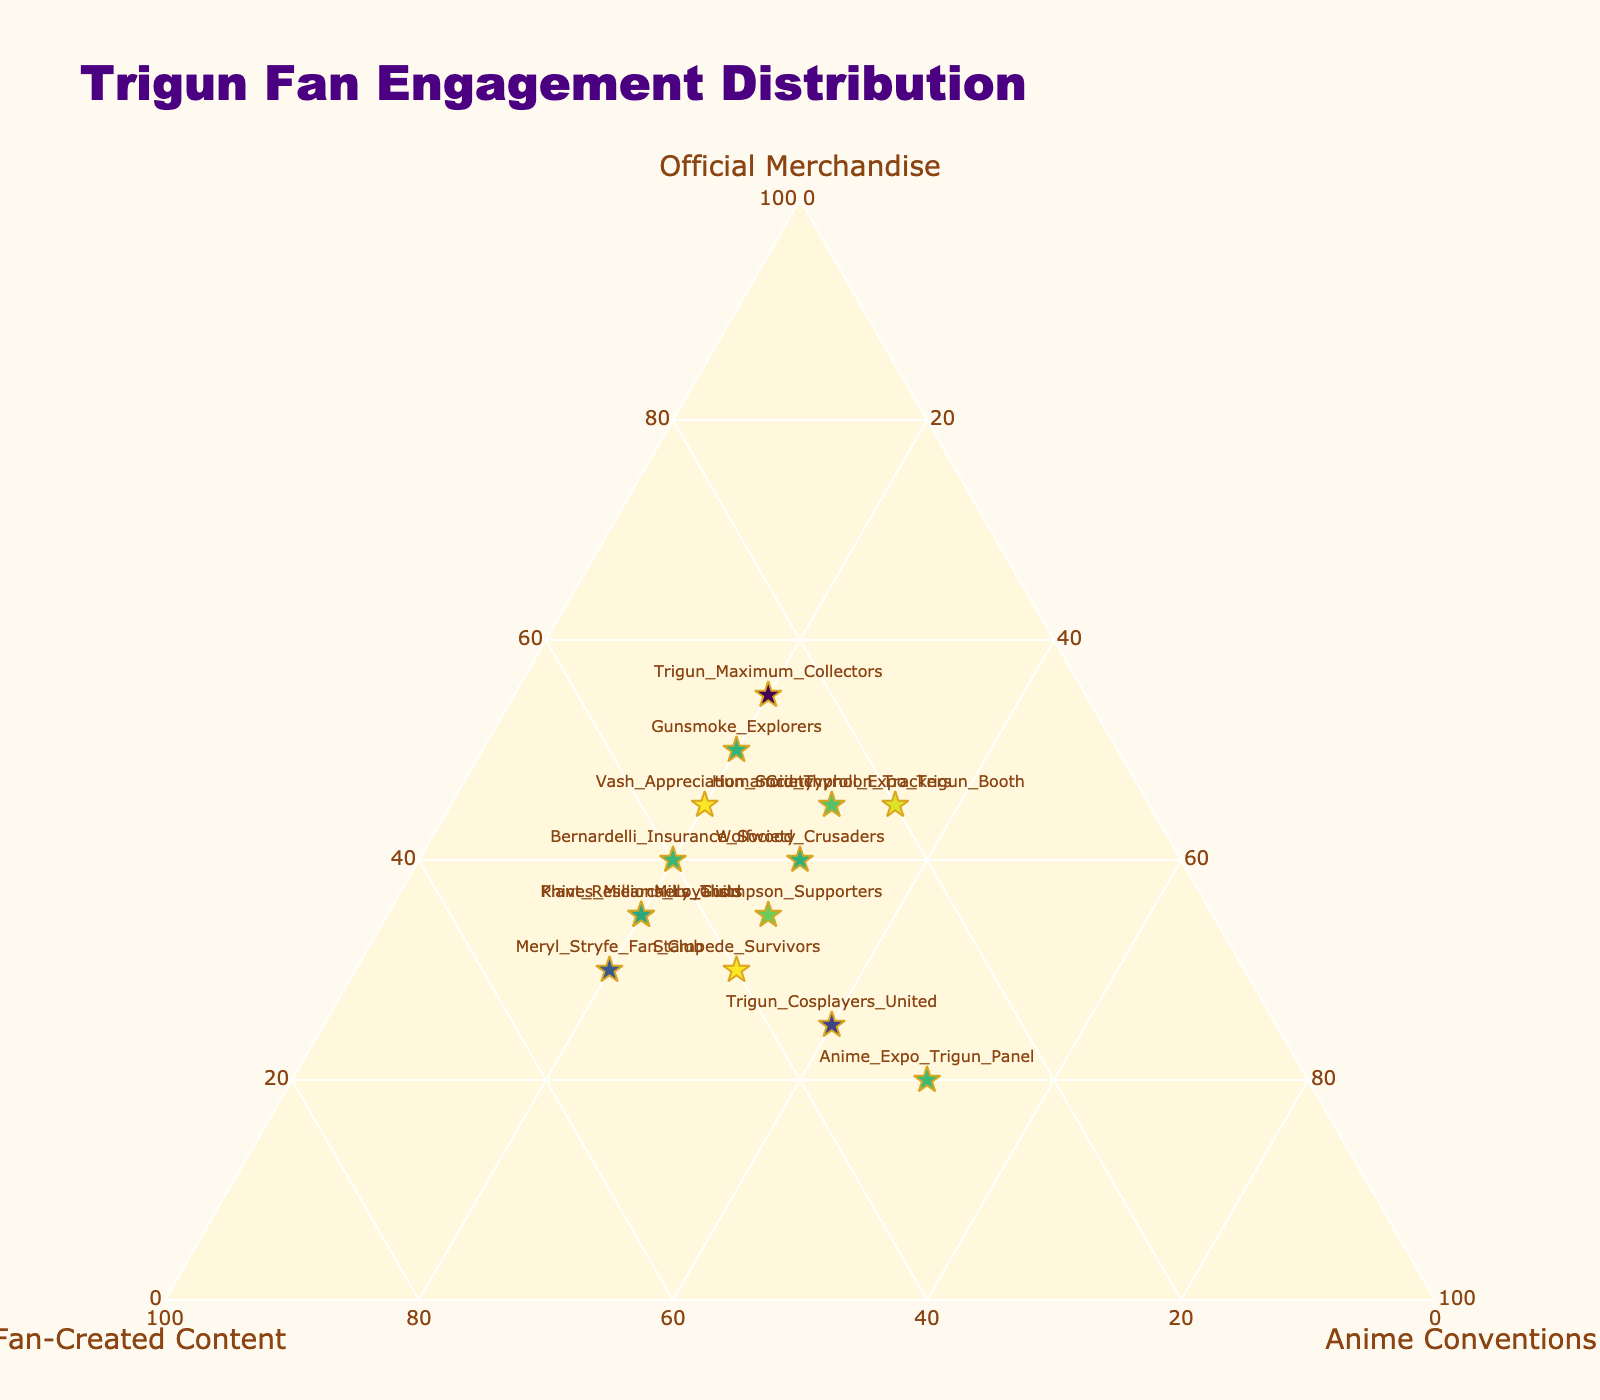What is the title of the figure? The title is typically displayed at the top of the plot, clearly indicating what the plot is about. The title text is larger and more prominent to catch the viewer's attention immediately.
Answer: Trigun Fan Engagement Distribution How many fan groups are represented in the plot? By counting the number of unique labels displayed on the plot, one can determine the total number of fan groups.
Answer: 14 Which fan group has the highest percentage of engagement in official merchandise? To determine this, look at the data points along the axis labeled 'Official Merchandise' and identify the highest value.
Answer: Trigun Maximum Collectors What is the median value of official merchandise engagement from all fan groups? List all the engagement values for official merchandise, sort them in ascending order, and find the middle value. If there's an even number of values, take the average of the two central numbers.
Answer: 37.5 Which fan group focuses more on anime conventions compared to other activities? Find the data point that lies furthest along the axis labeled 'Anime Conventions'. This will indicate the highest engagement percentage in that category.
Answer: Anime Expo Trigun Panel Compare the Vash Appreciation Society and Knives Millions Loyalists in terms of their engagement in fan-created content. Which one has more? Examine the values for 'Fan-Created Content' for both groups and compare them directly.
Answer: Knives Millions Loyalists Which fan group has the most balanced engagement across all three activities? Look for the data point closest to the center of the ternary plot, indicating a more even distribution among the three categories.
Answer: Bernardelli Insurance Society What percentage of Gunsmoke Explorers' engagement goes into fan-created content? Locate the Gunsmoke Explorers on the plot and read off the value next to the 'Fan-Created Content' axis.
Answer: 30 Find the average percentage of anime conventions engagement across all fan groups. Add up all the percentages for 'Anime Conventions' and divide by the number of fan groups to find the mean.
Answer: 28.57 Which fan group has the closest level of engagement in official merchandise and fan-created content? Identify data points where the values for 'Official Merchandise' and 'Fan-Created Content' are closest to each other.
Answer: Bernardelli Insurance Society 